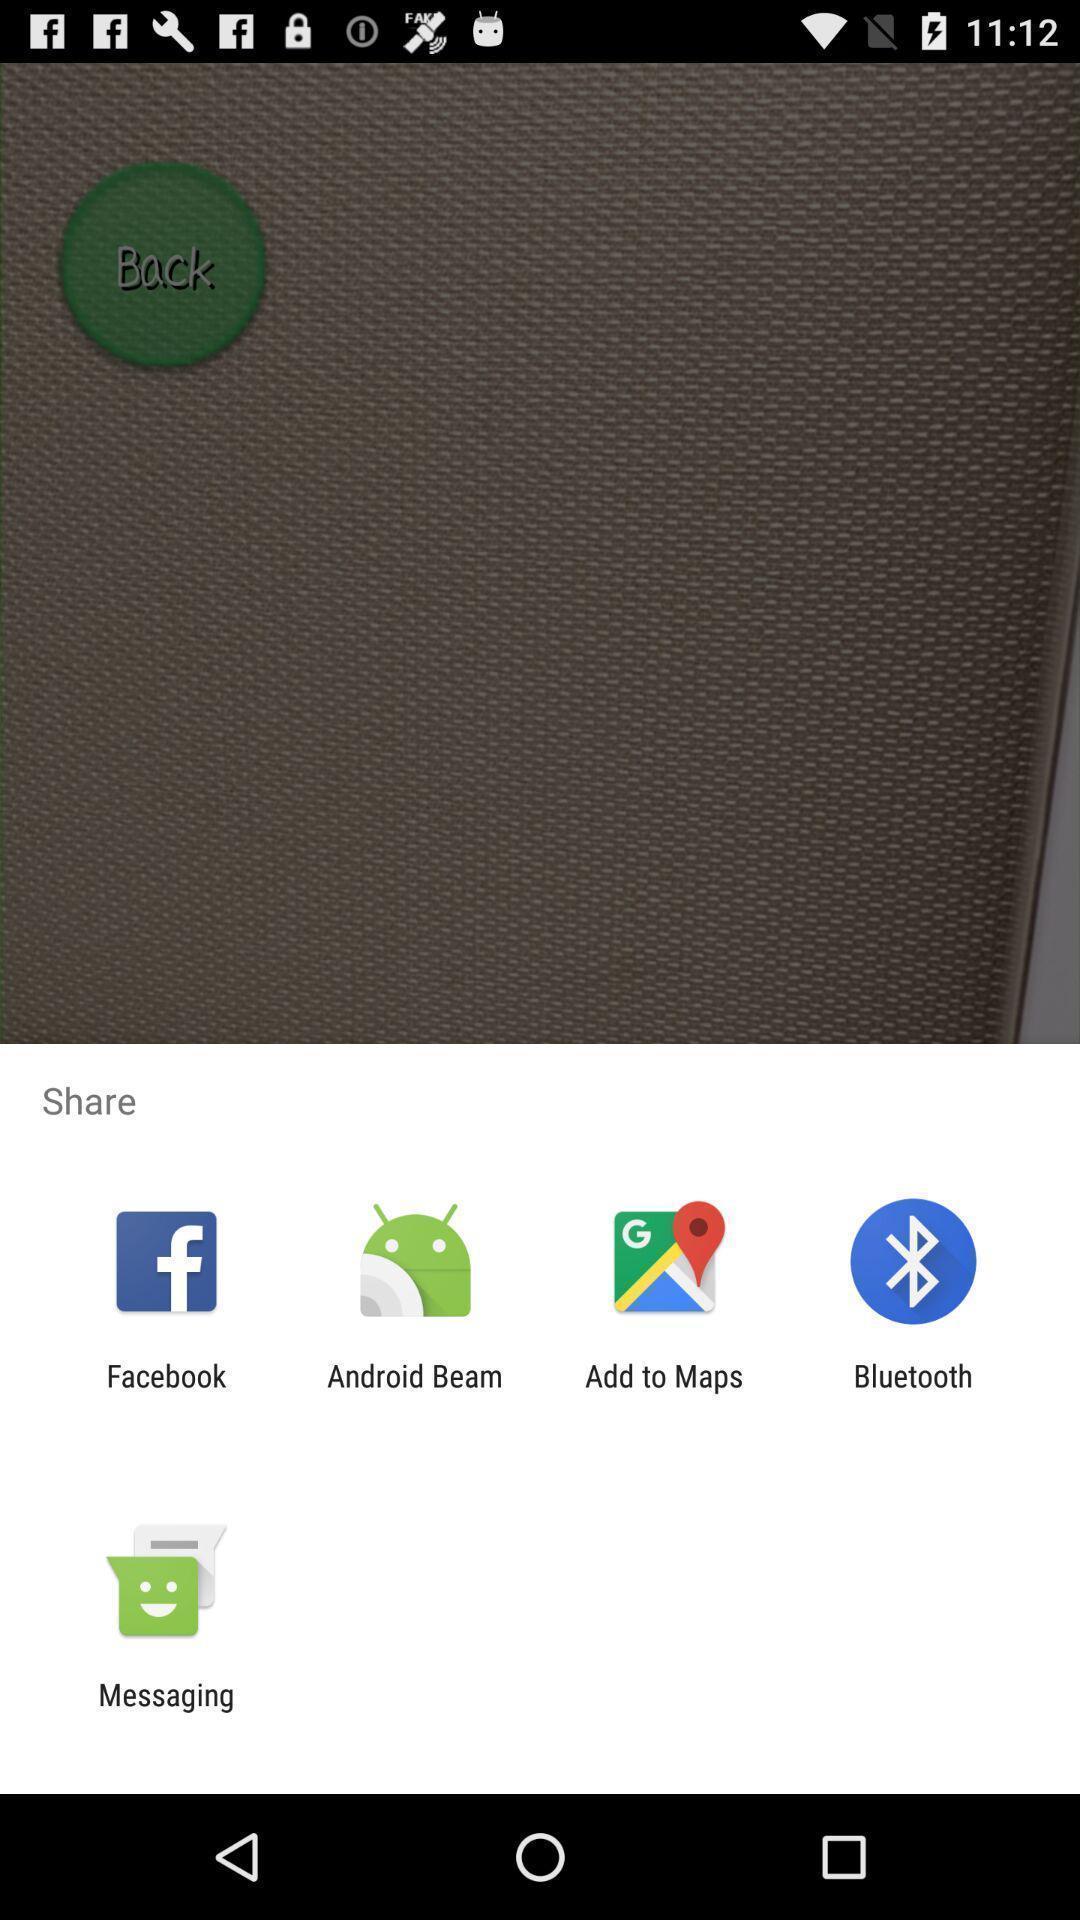Describe this image in words. Pop up showing various apps to share. 